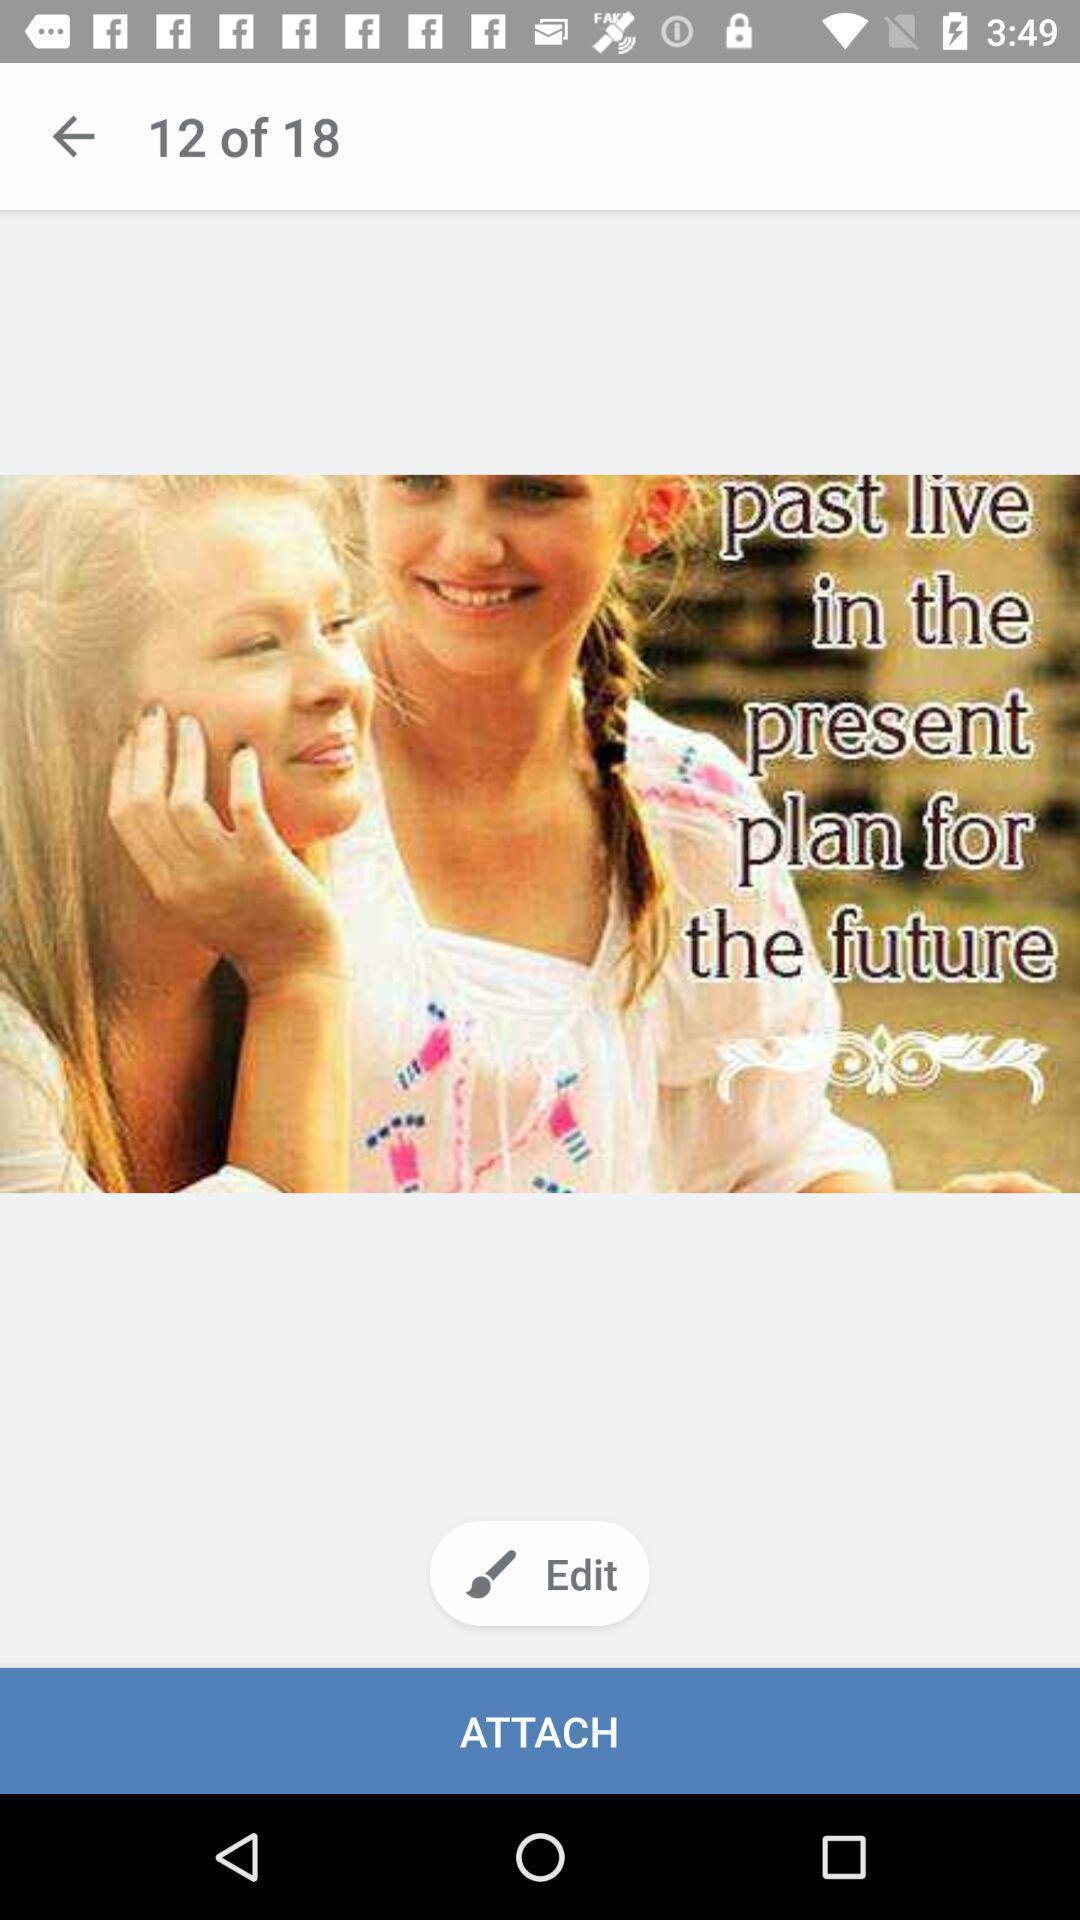Summarize the information in this screenshot. Page displaying the image. 